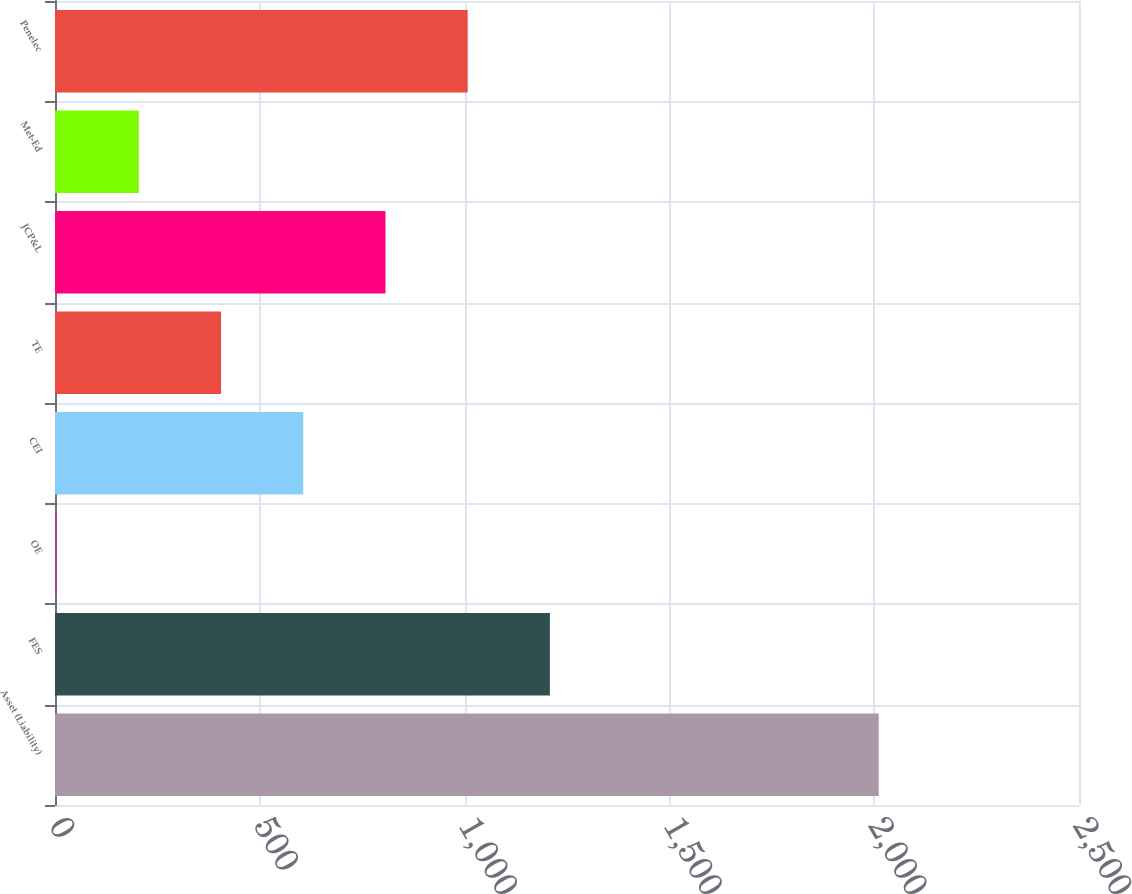Convert chart to OTSL. <chart><loc_0><loc_0><loc_500><loc_500><bar_chart><fcel>Asset (Liability)<fcel>FES<fcel>OE<fcel>CEI<fcel>TE<fcel>JCP&L<fcel>Met-Ed<fcel>Penelec<nl><fcel>2011<fcel>1208.2<fcel>4<fcel>606.1<fcel>405.4<fcel>806.8<fcel>204.7<fcel>1007.5<nl></chart> 